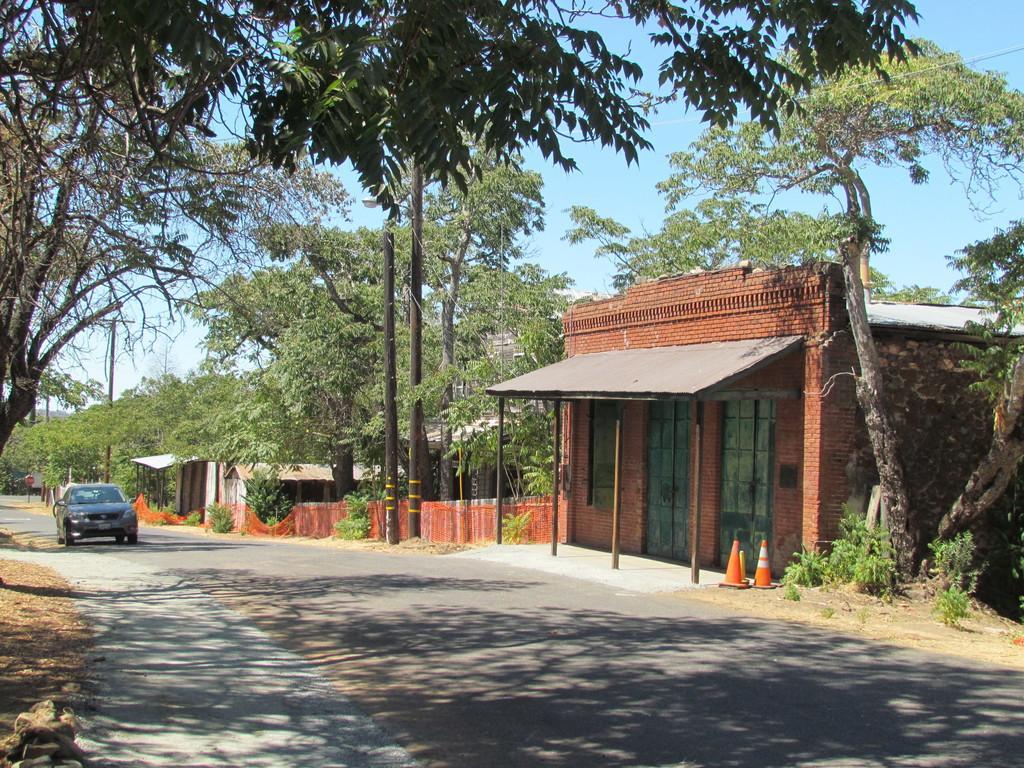Describe this image in one or two sentences. In this picture I can see a car on the road. On the right side I can see building, trees and traffic cones. In the background I can see the sky. 